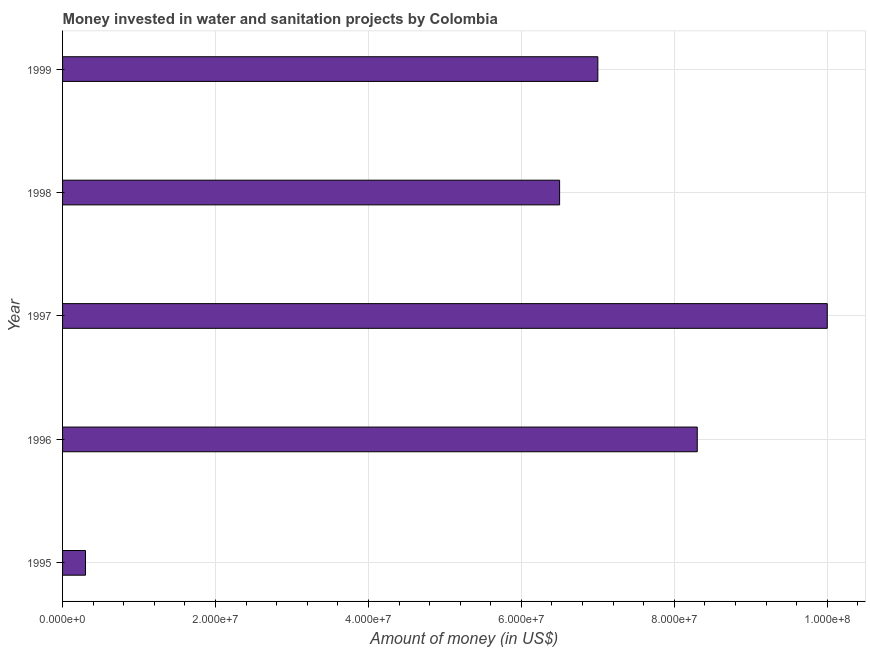What is the title of the graph?
Ensure brevity in your answer.  Money invested in water and sanitation projects by Colombia. What is the label or title of the X-axis?
Provide a succinct answer. Amount of money (in US$). What is the investment in 1998?
Provide a short and direct response. 6.50e+07. Across all years, what is the minimum investment?
Your response must be concise. 3.00e+06. In which year was the investment minimum?
Provide a succinct answer. 1995. What is the sum of the investment?
Make the answer very short. 3.21e+08. What is the difference between the investment in 1997 and 1998?
Your answer should be very brief. 3.50e+07. What is the average investment per year?
Keep it short and to the point. 6.42e+07. What is the median investment?
Ensure brevity in your answer.  7.00e+07. In how many years, is the investment greater than 16000000 US$?
Your answer should be very brief. 4. What is the ratio of the investment in 1995 to that in 1999?
Provide a short and direct response. 0.04. Is the difference between the investment in 1995 and 1998 greater than the difference between any two years?
Your answer should be compact. No. What is the difference between the highest and the second highest investment?
Your response must be concise. 1.70e+07. What is the difference between the highest and the lowest investment?
Offer a terse response. 9.70e+07. In how many years, is the investment greater than the average investment taken over all years?
Keep it short and to the point. 4. Are all the bars in the graph horizontal?
Make the answer very short. Yes. How many years are there in the graph?
Your answer should be very brief. 5. Are the values on the major ticks of X-axis written in scientific E-notation?
Ensure brevity in your answer.  Yes. What is the Amount of money (in US$) in 1995?
Keep it short and to the point. 3.00e+06. What is the Amount of money (in US$) of 1996?
Ensure brevity in your answer.  8.30e+07. What is the Amount of money (in US$) in 1997?
Your answer should be compact. 1.00e+08. What is the Amount of money (in US$) in 1998?
Give a very brief answer. 6.50e+07. What is the Amount of money (in US$) of 1999?
Give a very brief answer. 7.00e+07. What is the difference between the Amount of money (in US$) in 1995 and 1996?
Your answer should be compact. -8.00e+07. What is the difference between the Amount of money (in US$) in 1995 and 1997?
Keep it short and to the point. -9.70e+07. What is the difference between the Amount of money (in US$) in 1995 and 1998?
Keep it short and to the point. -6.20e+07. What is the difference between the Amount of money (in US$) in 1995 and 1999?
Your response must be concise. -6.70e+07. What is the difference between the Amount of money (in US$) in 1996 and 1997?
Your answer should be compact. -1.70e+07. What is the difference between the Amount of money (in US$) in 1996 and 1998?
Give a very brief answer. 1.80e+07. What is the difference between the Amount of money (in US$) in 1996 and 1999?
Provide a short and direct response. 1.30e+07. What is the difference between the Amount of money (in US$) in 1997 and 1998?
Keep it short and to the point. 3.50e+07. What is the difference between the Amount of money (in US$) in 1997 and 1999?
Provide a succinct answer. 3.00e+07. What is the difference between the Amount of money (in US$) in 1998 and 1999?
Ensure brevity in your answer.  -5.00e+06. What is the ratio of the Amount of money (in US$) in 1995 to that in 1996?
Provide a succinct answer. 0.04. What is the ratio of the Amount of money (in US$) in 1995 to that in 1998?
Offer a very short reply. 0.05. What is the ratio of the Amount of money (in US$) in 1995 to that in 1999?
Ensure brevity in your answer.  0.04. What is the ratio of the Amount of money (in US$) in 1996 to that in 1997?
Make the answer very short. 0.83. What is the ratio of the Amount of money (in US$) in 1996 to that in 1998?
Make the answer very short. 1.28. What is the ratio of the Amount of money (in US$) in 1996 to that in 1999?
Make the answer very short. 1.19. What is the ratio of the Amount of money (in US$) in 1997 to that in 1998?
Your answer should be very brief. 1.54. What is the ratio of the Amount of money (in US$) in 1997 to that in 1999?
Your answer should be very brief. 1.43. What is the ratio of the Amount of money (in US$) in 1998 to that in 1999?
Make the answer very short. 0.93. 